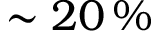Convert formula to latex. <formula><loc_0><loc_0><loc_500><loc_500>\sim 2 0 \, \%</formula> 